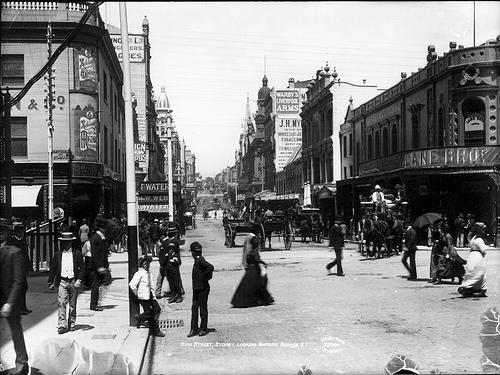Is this a busy town?
Quick response, please. Yes. Was this photo taken yesterday?
Give a very brief answer. No. How many cars are there?
Answer briefly. 0. 